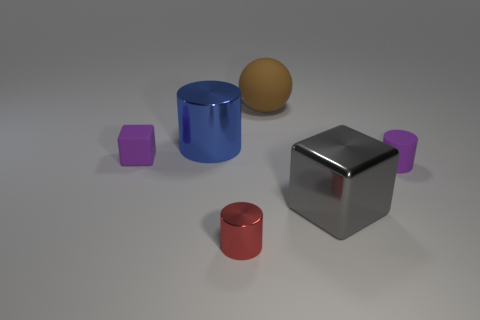What shape is the thing that is the same color as the matte block?
Make the answer very short. Cylinder. How many other things are there of the same material as the blue thing?
Provide a succinct answer. 2. What is the color of the cylinder behind the purple object right of the tiny purple thing that is behind the small matte cylinder?
Your answer should be compact. Blue. There is a purple matte object that is in front of the tiny purple thing on the left side of the large brown object; what is its shape?
Ensure brevity in your answer.  Cylinder. Is the number of matte cylinders behind the blue metallic cylinder greater than the number of large brown cubes?
Provide a short and direct response. No. There is a big object behind the big blue metallic thing; does it have the same shape as the big blue object?
Your answer should be very brief. No. Is there another big matte thing of the same shape as the blue thing?
Provide a short and direct response. No. What number of objects are either tiny matte things that are behind the small purple cylinder or big brown shiny blocks?
Your answer should be very brief. 1. Is the number of big gray blocks greater than the number of big purple rubber balls?
Your answer should be compact. Yes. Are there any purple rubber blocks that have the same size as the red metallic object?
Ensure brevity in your answer.  Yes. 